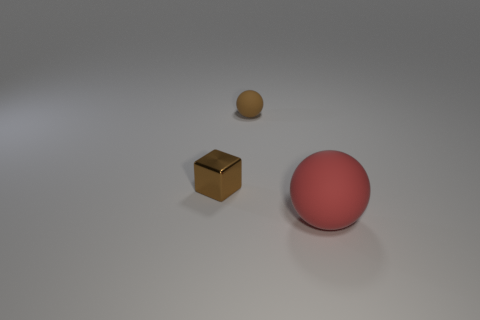What materials do the objects in the image seem to be made of? The objects in the image give the impression of being made from different materials: the sphere looks like it might be metallic due to its reflective surface, the cube suggests a wooden texture, and the smaller sphere seems to have a matte finish that could be ceramic or plastic. 